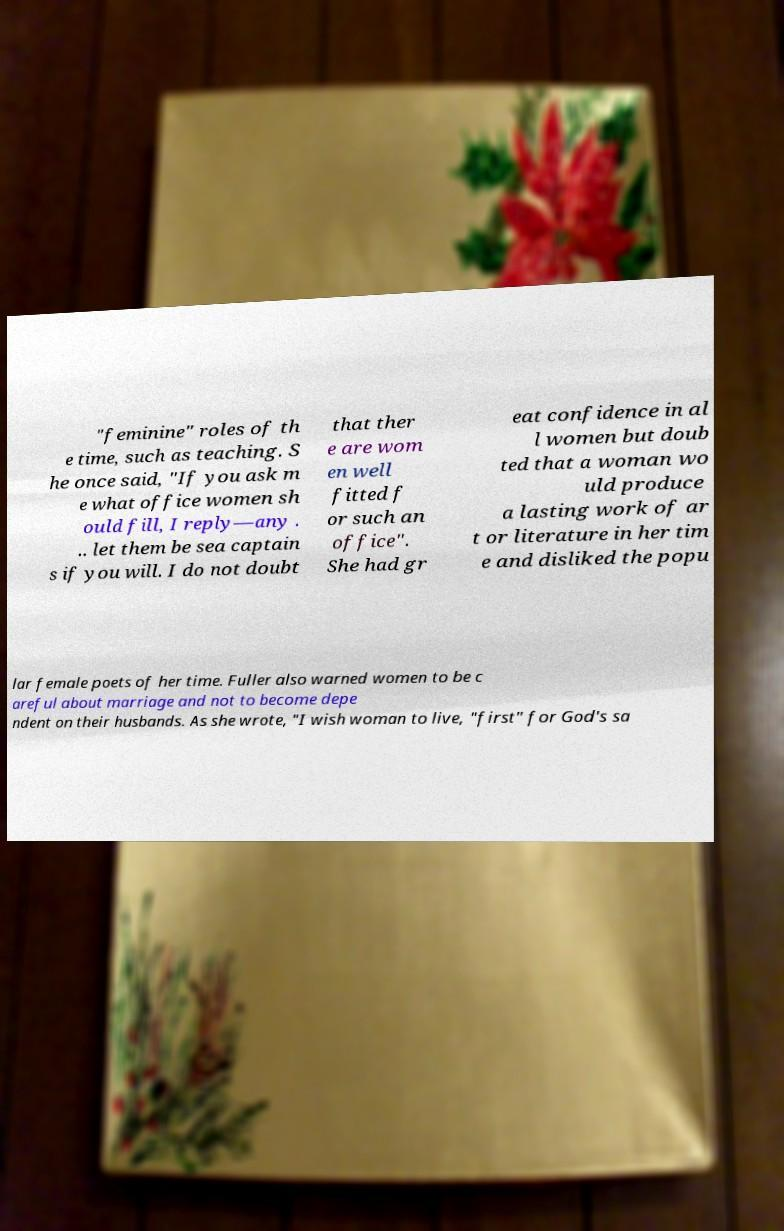Can you read and provide the text displayed in the image?This photo seems to have some interesting text. Can you extract and type it out for me? "feminine" roles of th e time, such as teaching. S he once said, "If you ask m e what office women sh ould fill, I reply—any . .. let them be sea captain s if you will. I do not doubt that ther e are wom en well fitted f or such an office". She had gr eat confidence in al l women but doub ted that a woman wo uld produce a lasting work of ar t or literature in her tim e and disliked the popu lar female poets of her time. Fuller also warned women to be c areful about marriage and not to become depe ndent on their husbands. As she wrote, "I wish woman to live, "first" for God's sa 